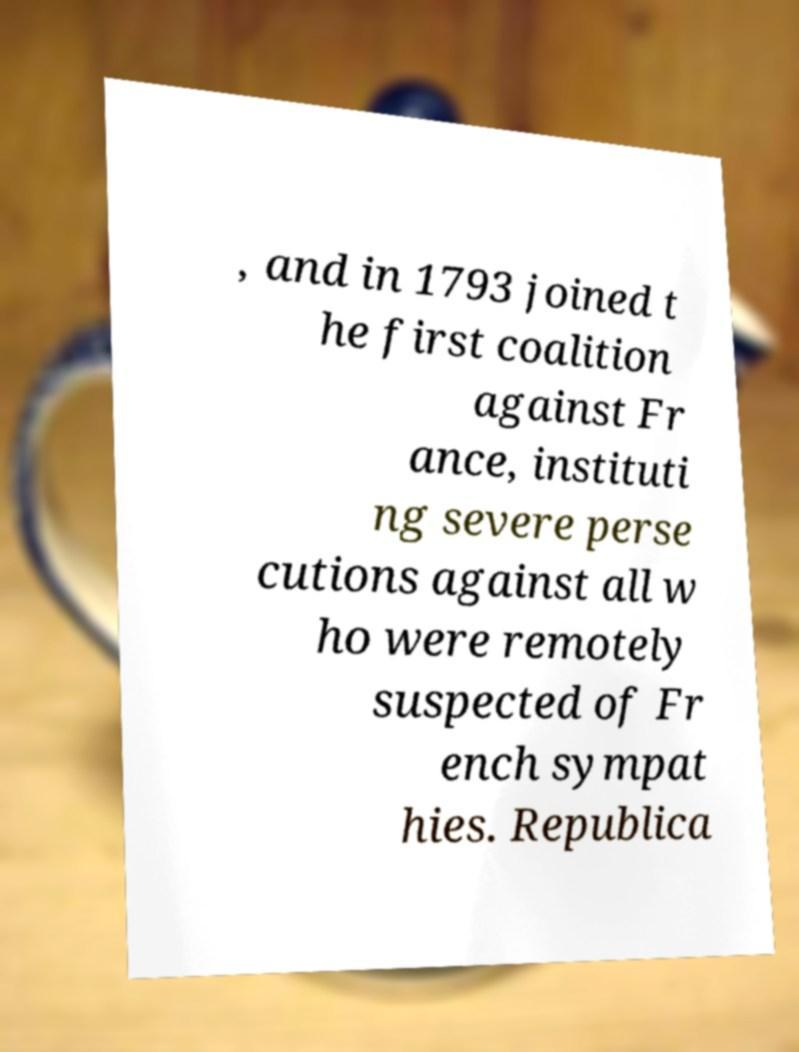Please identify and transcribe the text found in this image. , and in 1793 joined t he first coalition against Fr ance, instituti ng severe perse cutions against all w ho were remotely suspected of Fr ench sympat hies. Republica 